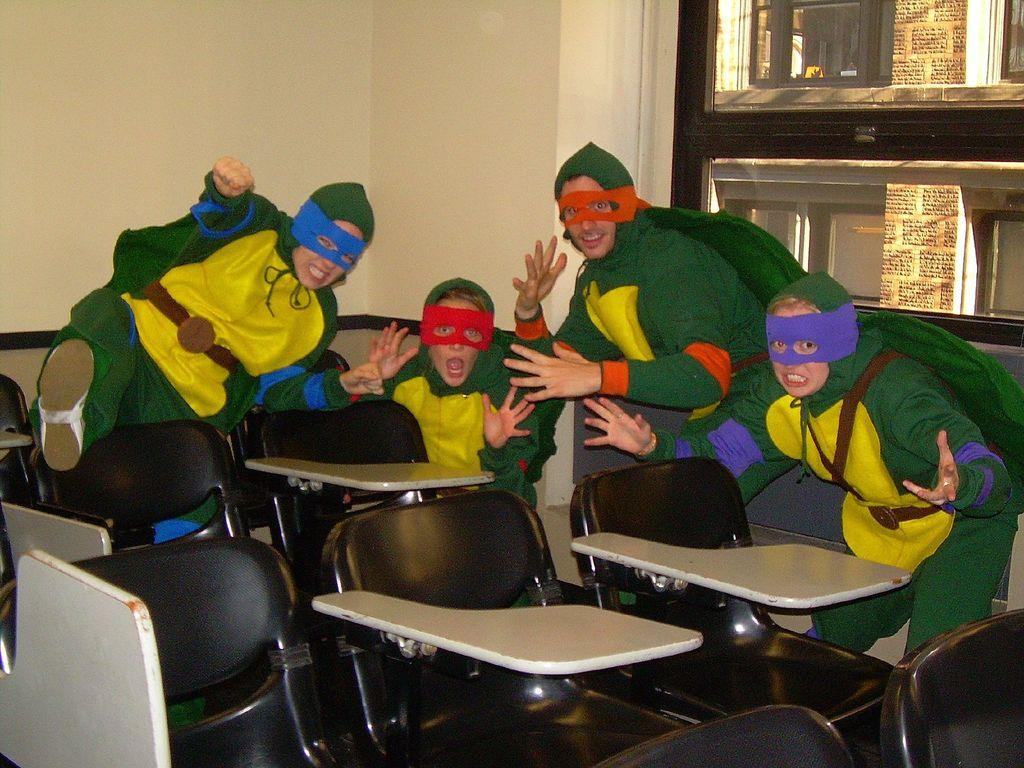How many people are in the room? There are children and a man in the room, so there are at least three people in the room. What are the children and the man wearing? The children and the man are wearing costumes and masks on their faces. What are they doing while wearing the costumes and masks? They are sitting in chairs. What can be seen in the background of the room? There is a wall in the background of the room. What type of bear can be seen in the room? There is no bear present in the room; the people in the room are wearing costumes and masks, but they are not bears. How many ducks are sitting on the chairs with the children and the man? There are no ducks present in the room; the people in the room are sitting in chairs, but they are not ducks. 